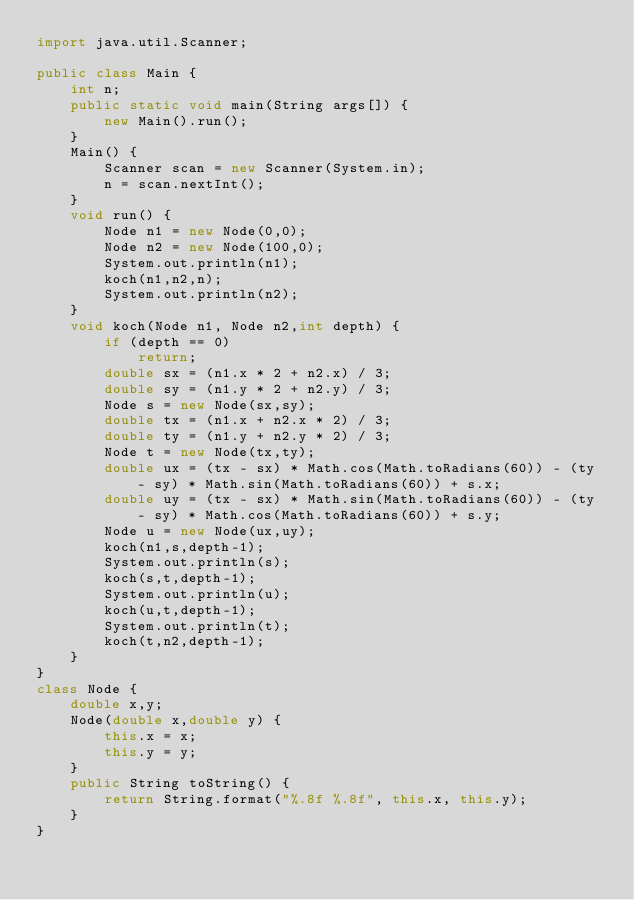Convert code to text. <code><loc_0><loc_0><loc_500><loc_500><_Java_>import java.util.Scanner;

public class Main {
	int n;
	public static void main(String args[]) {
		new Main().run();
	}
	Main() {
		Scanner scan = new Scanner(System.in);
		n = scan.nextInt();
	}
	void run() {
		Node n1 = new Node(0,0);
		Node n2 = new Node(100,0);
		System.out.println(n1);
		koch(n1,n2,n);
		System.out.println(n2);
	}
	void koch(Node n1, Node n2,int depth) {
		if (depth == 0)
			return;
		double sx = (n1.x * 2 + n2.x) / 3;
		double sy = (n1.y * 2 + n2.y) / 3;
		Node s = new Node(sx,sy);
		double tx = (n1.x + n2.x * 2) / 3;
		double ty = (n1.y + n2.y * 2) / 3;
		Node t = new Node(tx,ty);
		double ux = (tx - sx) * Math.cos(Math.toRadians(60)) - (ty - sy) * Math.sin(Math.toRadians(60)) + s.x;
		double uy = (tx - sx) * Math.sin(Math.toRadians(60)) - (ty - sy) * Math.cos(Math.toRadians(60)) + s.y;
		Node u = new Node(ux,uy);
		koch(n1,s,depth-1);
		System.out.println(s);
		koch(s,t,depth-1);
		System.out.println(u);
		koch(u,t,depth-1);
		System.out.println(t);
		koch(t,n2,depth-1);
	}
}
class Node {
	double x,y;
	Node(double x,double y) {
		this.x = x;
		this.y = y;
	}
	public String toString() {
		return String.format("%.8f %.8f", this.x, this.y);
	}
}

</code> 